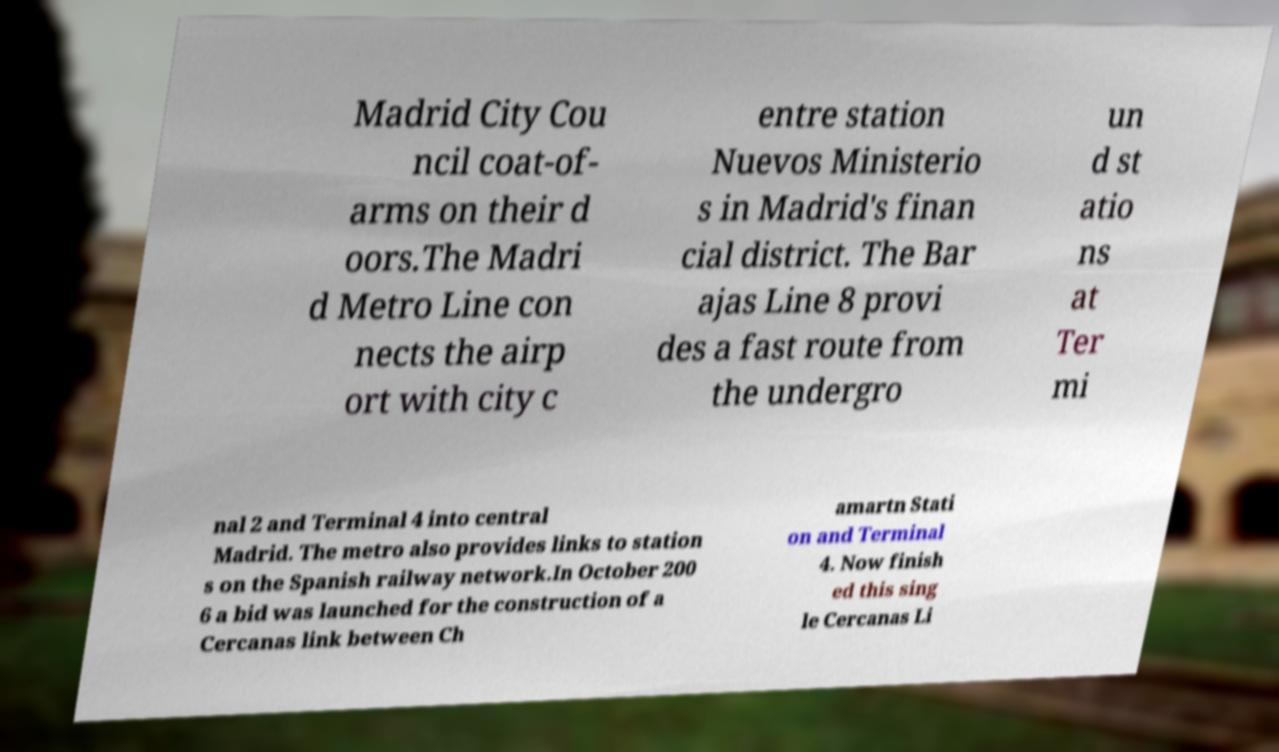I need the written content from this picture converted into text. Can you do that? Madrid City Cou ncil coat-of- arms on their d oors.The Madri d Metro Line con nects the airp ort with city c entre station Nuevos Ministerio s in Madrid's finan cial district. The Bar ajas Line 8 provi des a fast route from the undergro un d st atio ns at Ter mi nal 2 and Terminal 4 into central Madrid. The metro also provides links to station s on the Spanish railway network.In October 200 6 a bid was launched for the construction of a Cercanas link between Ch amartn Stati on and Terminal 4. Now finish ed this sing le Cercanas Li 